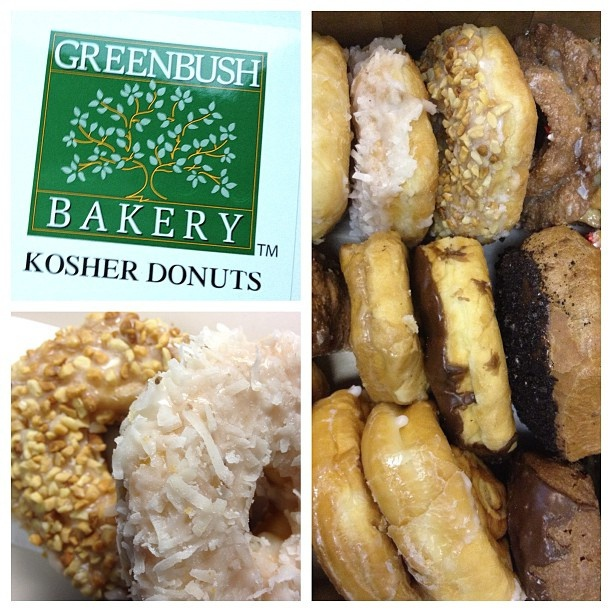Describe the objects in this image and their specific colors. I can see donut in white, darkgray, lightgray, and tan tones, donut in white, tan, and olive tones, donut in white, black, tan, gray, and olive tones, donut in white and tan tones, and donut in white and tan tones in this image. 